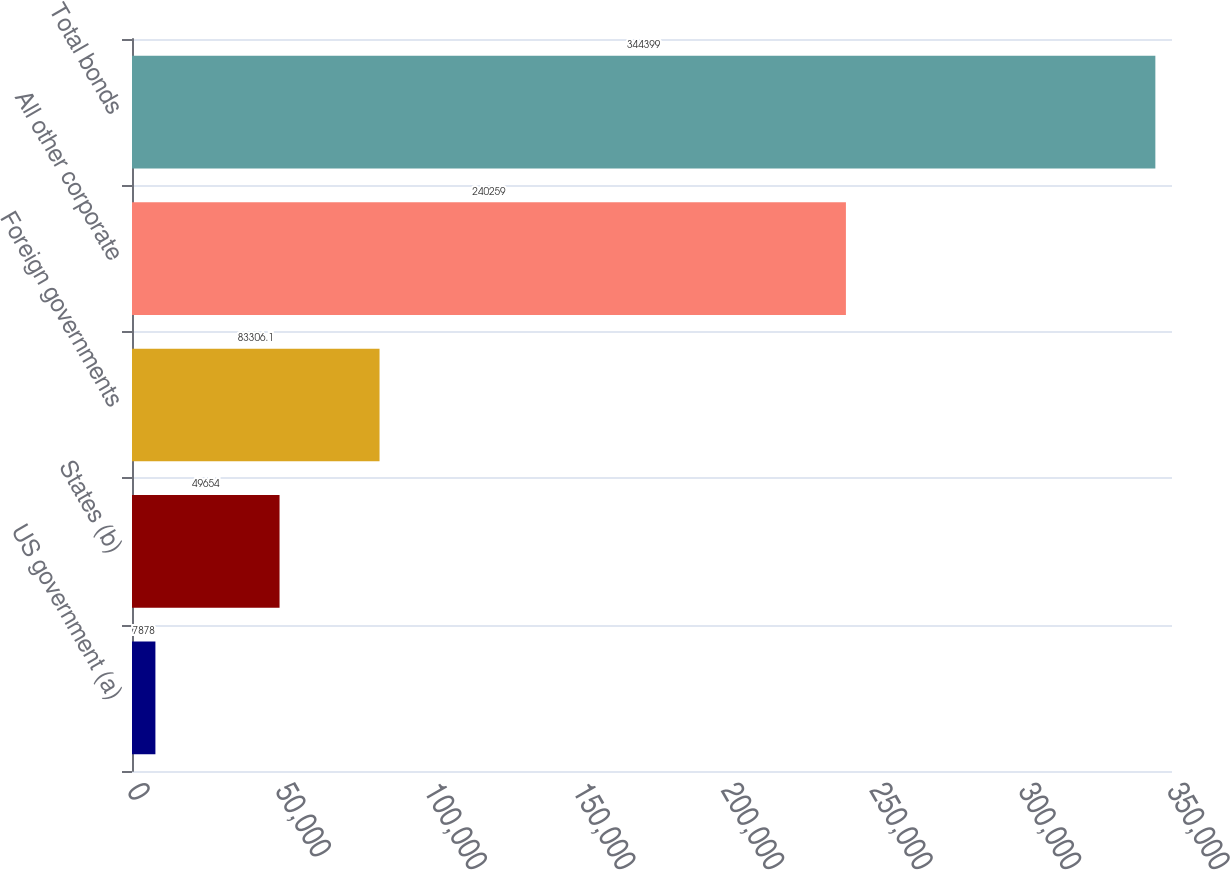Convert chart to OTSL. <chart><loc_0><loc_0><loc_500><loc_500><bar_chart><fcel>US government (a)<fcel>States (b)<fcel>Foreign governments<fcel>All other corporate<fcel>Total bonds<nl><fcel>7878<fcel>49654<fcel>83306.1<fcel>240259<fcel>344399<nl></chart> 